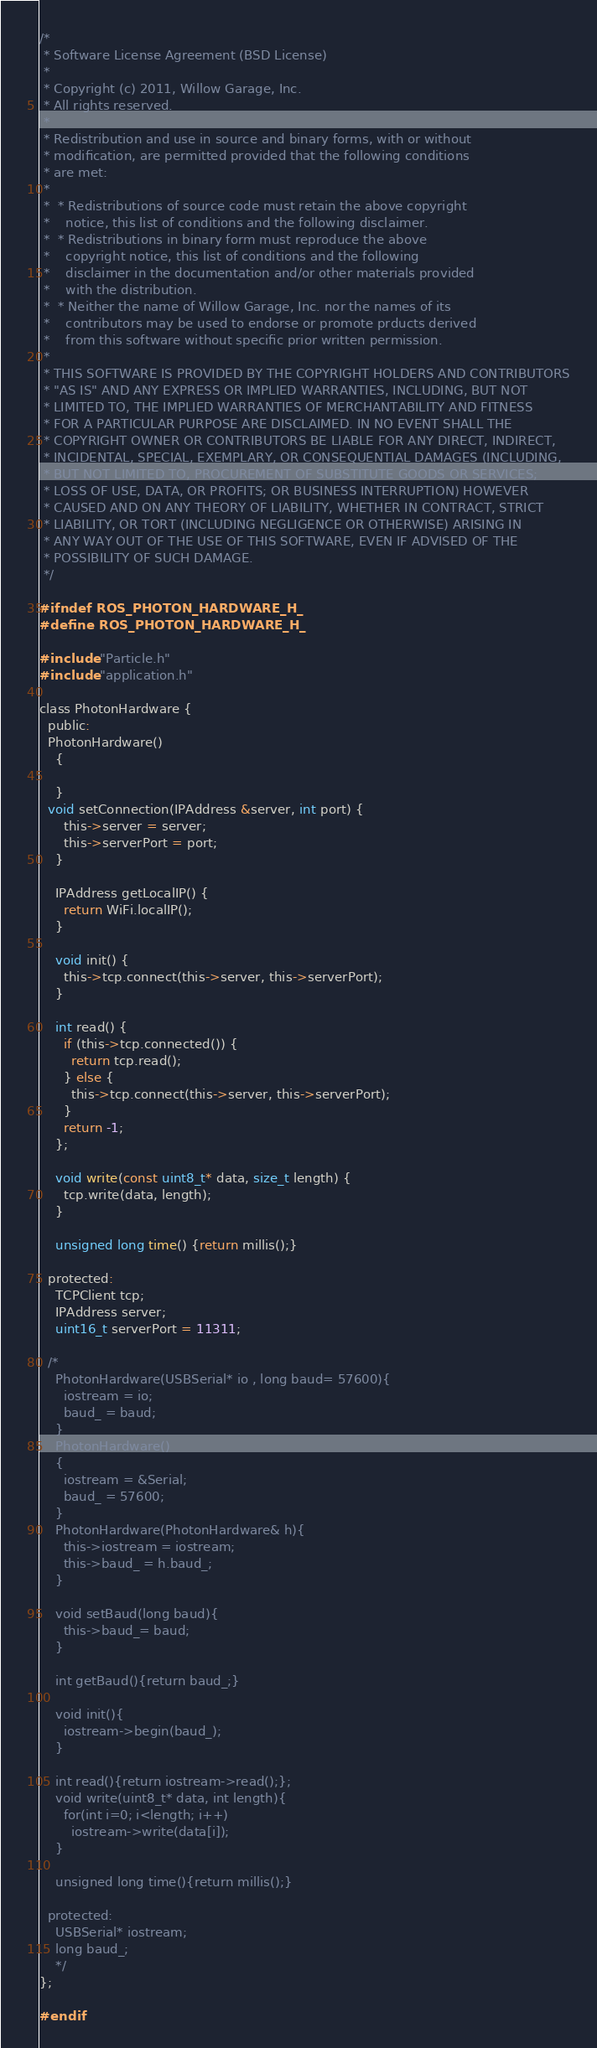<code> <loc_0><loc_0><loc_500><loc_500><_C_>/* 
 * Software License Agreement (BSD License)
 *
 * Copyright (c) 2011, Willow Garage, Inc.
 * All rights reserved.
 *
 * Redistribution and use in source and binary forms, with or without
 * modification, are permitted provided that the following conditions
 * are met:
 *
 *  * Redistributions of source code must retain the above copyright
 *    notice, this list of conditions and the following disclaimer.
 *  * Redistributions in binary form must reproduce the above
 *    copyright notice, this list of conditions and the following
 *    disclaimer in the documentation and/or other materials provided
 *    with the distribution.
 *  * Neither the name of Willow Garage, Inc. nor the names of its
 *    contributors may be used to endorse or promote prducts derived
 *    from this software without specific prior written permission.
 *
 * THIS SOFTWARE IS PROVIDED BY THE COPYRIGHT HOLDERS AND CONTRIBUTORS
 * "AS IS" AND ANY EXPRESS OR IMPLIED WARRANTIES, INCLUDING, BUT NOT
 * LIMITED TO, THE IMPLIED WARRANTIES OF MERCHANTABILITY AND FITNESS
 * FOR A PARTICULAR PURPOSE ARE DISCLAIMED. IN NO EVENT SHALL THE
 * COPYRIGHT OWNER OR CONTRIBUTORS BE LIABLE FOR ANY DIRECT, INDIRECT,
 * INCIDENTAL, SPECIAL, EXEMPLARY, OR CONSEQUENTIAL DAMAGES (INCLUDING,
 * BUT NOT LIMITED TO, PROCUREMENT OF SUBSTITUTE GOODS OR SERVICES;
 * LOSS OF USE, DATA, OR PROFITS; OR BUSINESS INTERRUPTION) HOWEVER
 * CAUSED AND ON ANY THEORY OF LIABILITY, WHETHER IN CONTRACT, STRICT
 * LIABILITY, OR TORT (INCLUDING NEGLIGENCE OR OTHERWISE) ARISING IN
 * ANY WAY OUT OF THE USE OF THIS SOFTWARE, EVEN IF ADVISED OF THE
 * POSSIBILITY OF SUCH DAMAGE.
 */

#ifndef ROS_PHOTON_HARDWARE_H_
#define ROS_PHOTON_HARDWARE_H_

#include "Particle.h"
#include "application.h"

class PhotonHardware {
  public:
  PhotonHardware()
    {

    }
  void setConnection(IPAddress &server, int port) {
      this->server = server;
      this->serverPort = port;
    }
    
    IPAddress getLocalIP() {
      return WiFi.localIP();
    }

    void init() { 
      this->tcp.connect(this->server, this->serverPort);
    }

    int read() {
      if (this->tcp.connected()) {
        return tcp.read();
      } else {
        this->tcp.connect(this->server, this->serverPort);
      }
      return -1;
    };
    
    void write(const uint8_t* data, size_t length) {
      tcp.write(data, length);
    }

    unsigned long time() {return millis();}

  protected:
    TCPClient tcp;
    IPAddress server; 
    uint16_t serverPort = 11311;
	
  /*
    PhotonHardware(USBSerial* io , long baud= 57600){
      iostream = io;
      baud_ = baud;
    }
    PhotonHardware()
    {
      iostream = &Serial;
      baud_ = 57600;
    }
    PhotonHardware(PhotonHardware& h){
      this->iostream = iostream;
      this->baud_ = h.baud_;
    }
  
    void setBaud(long baud){
      this->baud_= baud;
    }
  
    int getBaud(){return baud_;}

    void init(){
      iostream->begin(baud_);
    }

    int read(){return iostream->read();};
    void write(uint8_t* data, int length){
      for(int i=0; i<length; i++)
        iostream->write(data[i]);
    }

    unsigned long time(){return millis();}

  protected:
    USBSerial* iostream;
    long baud_;
	*/
};

#endif
</code> 